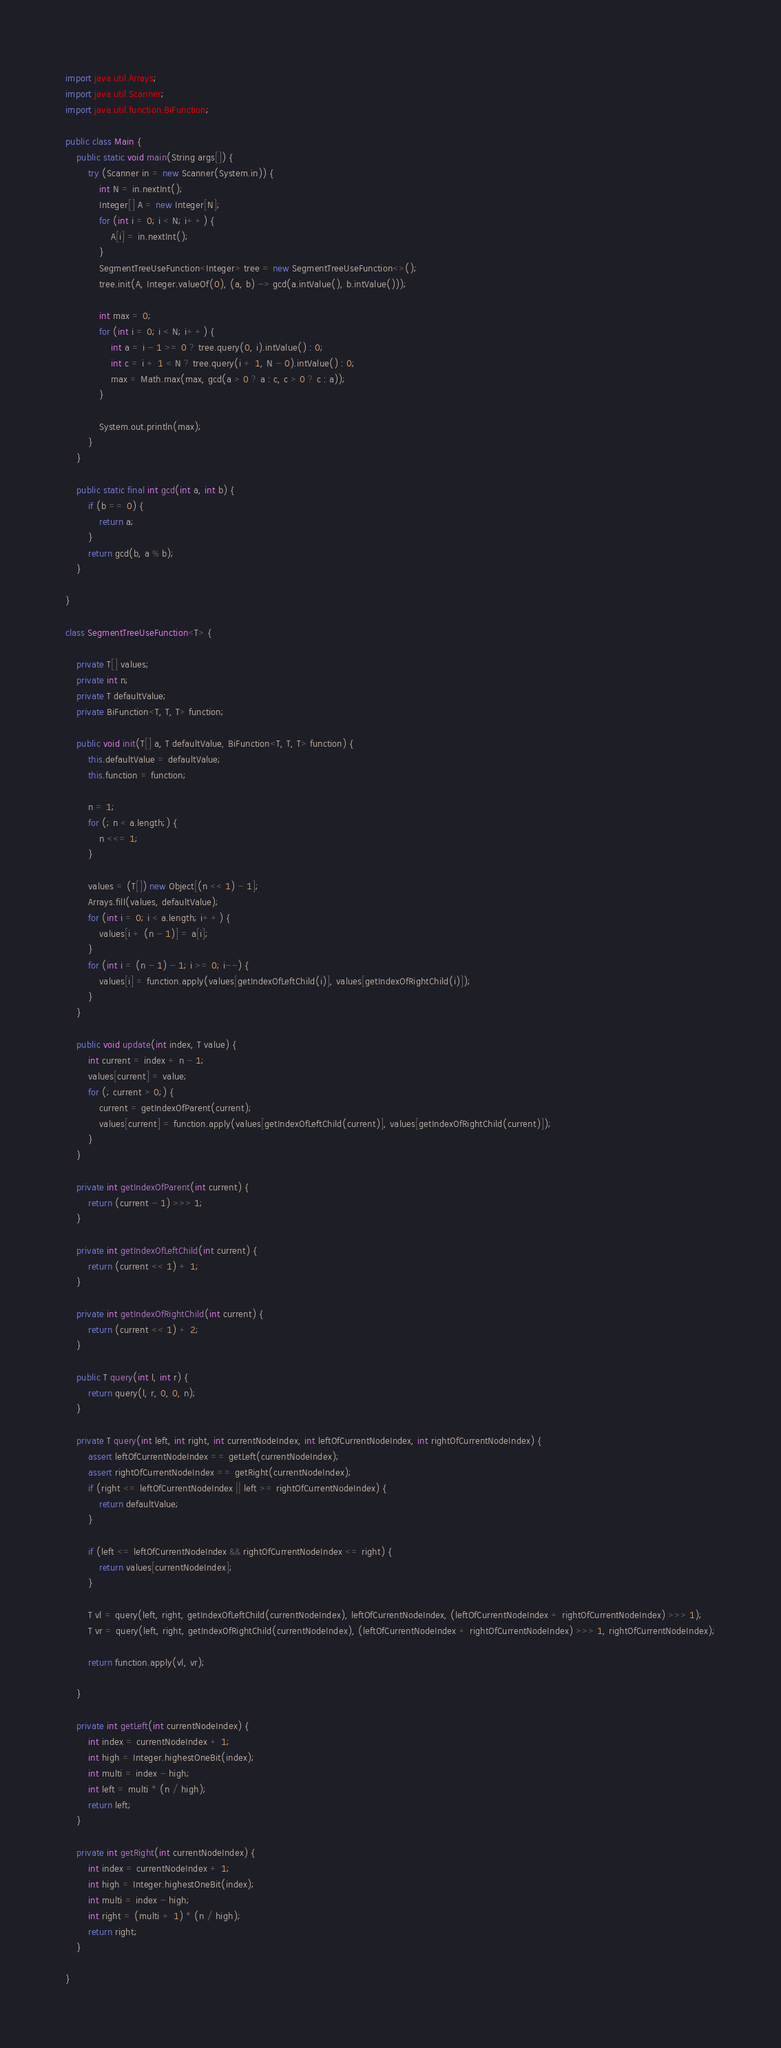Convert code to text. <code><loc_0><loc_0><loc_500><loc_500><_Java_>import java.util.Arrays;
import java.util.Scanner;
import java.util.function.BiFunction;

public class Main {
    public static void main(String args[]) {
        try (Scanner in = new Scanner(System.in)) {
            int N = in.nextInt();
            Integer[] A = new Integer[N];
            for (int i = 0; i < N; i++) {
                A[i] = in.nextInt();
            }
            SegmentTreeUseFunction<Integer> tree = new SegmentTreeUseFunction<>();
            tree.init(A, Integer.valueOf(0), (a, b) -> gcd(a.intValue(), b.intValue()));

            int max = 0;
            for (int i = 0; i < N; i++) {
                int a = i - 1 >= 0 ? tree.query(0, i).intValue() : 0;
                int c = i + 1 < N ? tree.query(i + 1, N - 0).intValue() : 0;
                max = Math.max(max, gcd(a > 0 ? a : c, c > 0 ? c : a));
            }

            System.out.println(max);
        }
    }

    public static final int gcd(int a, int b) {
        if (b == 0) {
            return a;
        }
        return gcd(b, a % b);
    }

}

class SegmentTreeUseFunction<T> {

    private T[] values;
    private int n;
    private T defaultValue;
    private BiFunction<T, T, T> function;

    public void init(T[] a, T defaultValue, BiFunction<T, T, T> function) {
        this.defaultValue = defaultValue;
        this.function = function;

        n = 1;
        for (; n < a.length;) {
            n <<= 1;
        }

        values = (T[]) new Object[(n << 1) - 1];
        Arrays.fill(values, defaultValue);
        for (int i = 0; i < a.length; i++) {
            values[i + (n - 1)] = a[i];
        }
        for (int i = (n - 1) - 1; i >= 0; i--) {
            values[i] = function.apply(values[getIndexOfLeftChild(i)], values[getIndexOfRightChild(i)]);
        }
    }

    public void update(int index, T value) {
        int current = index + n - 1;
        values[current] = value;
        for (; current > 0;) {
            current = getIndexOfParent(current);
            values[current] = function.apply(values[getIndexOfLeftChild(current)], values[getIndexOfRightChild(current)]);
        }
    }

    private int getIndexOfParent(int current) {
        return (current - 1) >>> 1;
    }

    private int getIndexOfLeftChild(int current) {
        return (current << 1) + 1;
    }

    private int getIndexOfRightChild(int current) {
        return (current << 1) + 2;
    }

    public T query(int l, int r) {
        return query(l, r, 0, 0, n);
    }

    private T query(int left, int right, int currentNodeIndex, int leftOfCurrentNodeIndex, int rightOfCurrentNodeIndex) {
        assert leftOfCurrentNodeIndex == getLeft(currentNodeIndex);
        assert rightOfCurrentNodeIndex == getRight(currentNodeIndex);
        if (right <= leftOfCurrentNodeIndex || left >= rightOfCurrentNodeIndex) {
            return defaultValue;
        }

        if (left <= leftOfCurrentNodeIndex && rightOfCurrentNodeIndex <= right) {
            return values[currentNodeIndex];
        }

        T vl = query(left, right, getIndexOfLeftChild(currentNodeIndex), leftOfCurrentNodeIndex, (leftOfCurrentNodeIndex + rightOfCurrentNodeIndex) >>> 1);
        T vr = query(left, right, getIndexOfRightChild(currentNodeIndex), (leftOfCurrentNodeIndex + rightOfCurrentNodeIndex) >>> 1, rightOfCurrentNodeIndex);

        return function.apply(vl, vr);

    }

    private int getLeft(int currentNodeIndex) {
        int index = currentNodeIndex + 1;
        int high = Integer.highestOneBit(index);
        int multi = index - high;
        int left = multi * (n / high);
        return left;
    }

    private int getRight(int currentNodeIndex) {
        int index = currentNodeIndex + 1;
        int high = Integer.highestOneBit(index);
        int multi = index - high;
        int right = (multi + 1) * (n / high);
        return right;
    }

}
</code> 